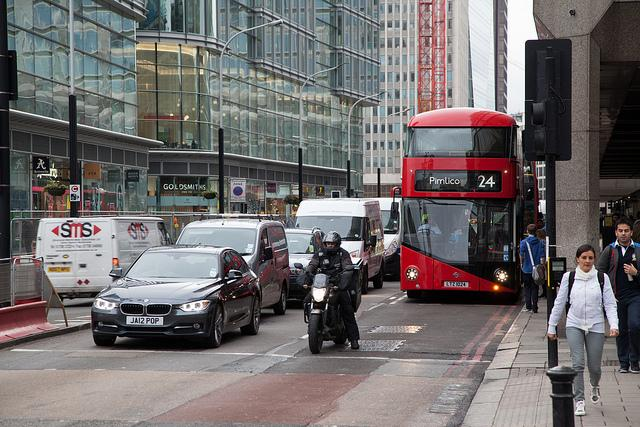What area of London does the bus go to? pimlico 